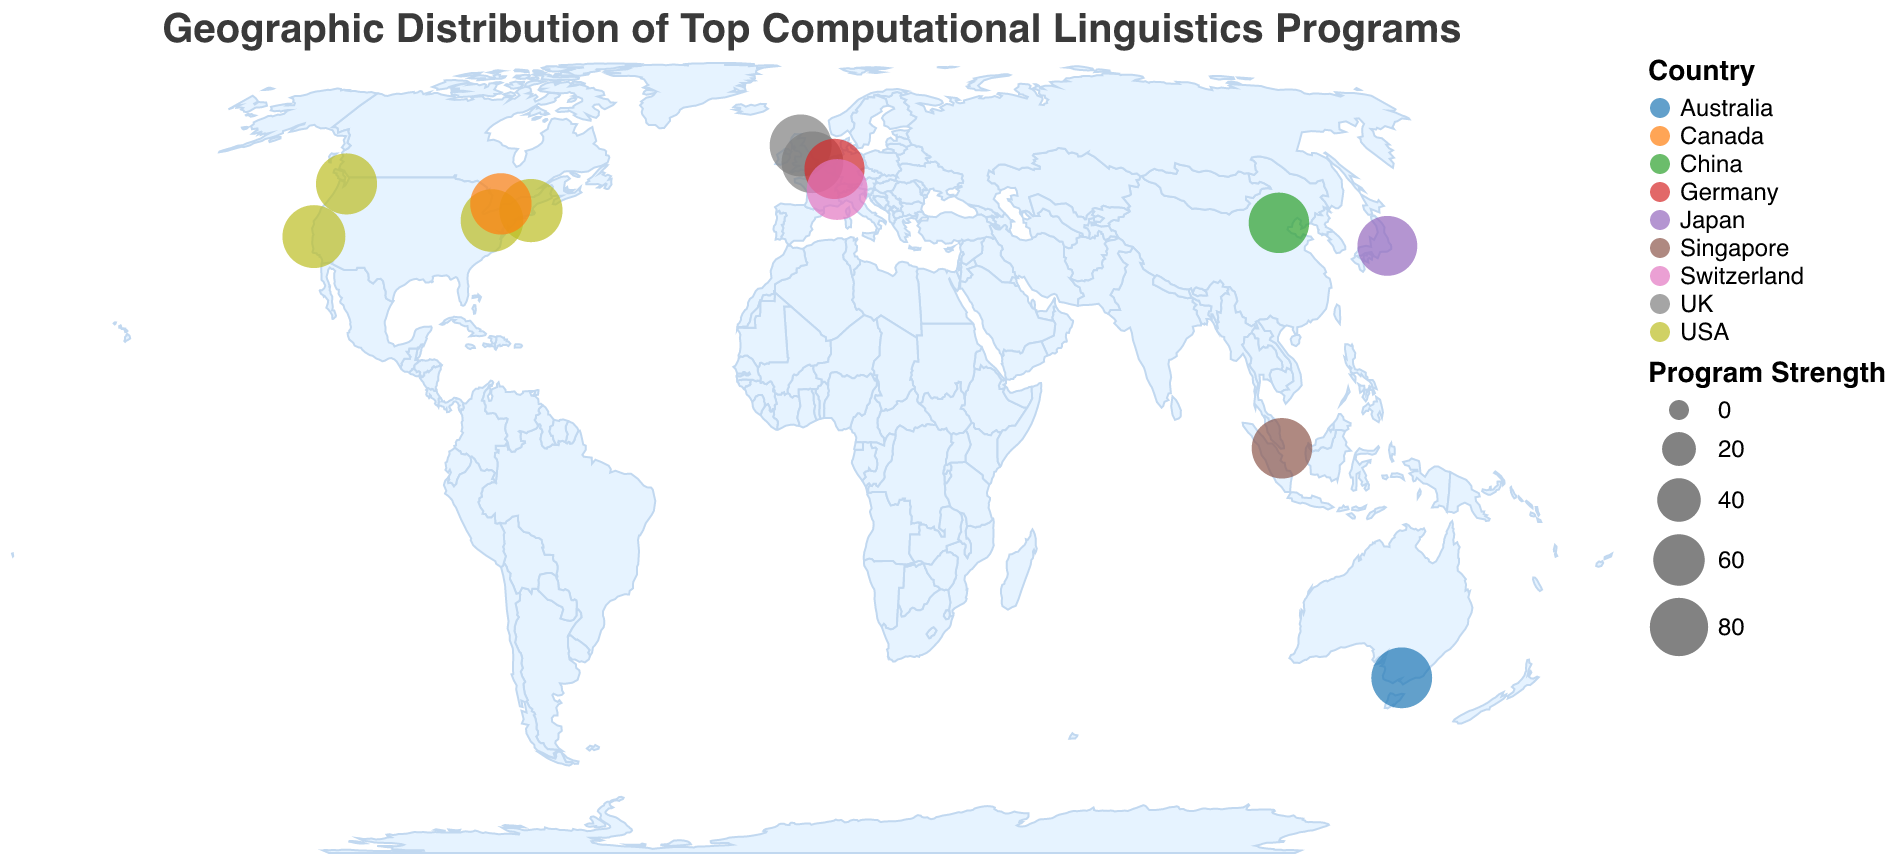What is the title of the figure? The title is located at the top of the figure. It reads "Geographic Distribution of Top Computational Linguistics Programs" based on the visual information provided.
Answer: Geographic Distribution of Top Computational Linguistics Programs How many institutions are marked in the USA? By looking at the geographic plot on the map, USA has circles indicating the universities. Count the circles in the USA, which are for Stanford University, Carnegie Mellon University, Massachusetts Institute of Technology, and University of Washington.
Answer: 4 Which institution has the highest Program Strength and where is it located? The largest circle on the plot, which corresponds to the highest Program Strength, is MIT. By checking the tooltip information, we see that MIT is located in Cambridge, USA, and its Program Strength is 96.
Answer: Massachusetts Institute of Technology, Cambridge, USA What colors represent institutions in the UK and how many are there? The color scheme legend denotes different colors for different countries. Locate the circles representing the UK and count them. The UK has two marked cities, Edinburgh and Cambridge, thus two institutions.
Answer: Two colors and 2 institutions Which continent has the most institutions represented in the plot? By observing the distribution of circles, North America (USA and Canada) has the highest number of circles representing institutions compared to other continents. North America has 5 institutions.
Answer: North America What is the average Program Strength of the institutions in the UK? Identify the institutions in the UK (University of Edinburgh and University of Cambridge) and their respective Program Strengths (92 and 91). Calculate the average: (92 + 91) / 2 = 91.5.
Answer: 91.5 Which institution in Asia has the strongest program? Check the circles in Asian countries and their tooltips to see Program Strength values. University of Tokyo in Japan has a Program Strength of 85, and Tsinghua University in China has 87. The largest circle in Asia is for Tsinghua University, indicating it's the strongest.
Answer: Tsinghua University Compare the Program Strength of the University of Toronto and National University of Singapore. Which one is stronger and by how much? Identify the Program Strength from the tooltips for both institutions: University of Toronto has 90, National University of Singapore has 87. The difference is 90 - 87 = 3.
Answer: University of Toronto is stronger by 3 Which European country has the highest number of represented institutions and what are their Program Strengths? Evaluate the circles in European countries. The UK has two institutions (University of Edinburgh at 92 and University of Cambridge at 91), whereas Switzerland and Germany have one each.
Answer: UK with Program Strengths 92 and 91 What is the latitude and longitude of RWTH Aachen University? Locate RWTH Aachen University on the map and check the tooltip for the geographical coordinates. The coordinates provided are 50.7784 (latitude) and 6.0683 (longitude).
Answer: Latitude 50.7784, Longitude 6.0683 